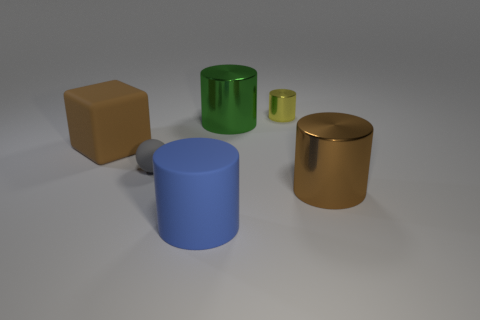Is the brown cylinder made of the same material as the small thing in front of the large brown cube?
Your answer should be very brief. No. There is a yellow cylinder that is to the right of the small object that is left of the green cylinder; how big is it?
Keep it short and to the point. Small. Are there any other things of the same color as the tiny cylinder?
Offer a very short reply. No. Do the big brown thing in front of the brown block and the large object that is to the left of the small gray sphere have the same material?
Offer a very short reply. No. There is a cylinder that is behind the tiny matte ball and on the left side of the tiny yellow metal cylinder; what material is it made of?
Give a very brief answer. Metal. There is a brown shiny thing; does it have the same shape as the shiny thing that is behind the big green object?
Your answer should be very brief. Yes. There is a cylinder right of the tiny object that is to the right of the big rubber thing in front of the large brown cylinder; what is it made of?
Provide a short and direct response. Metal. How many other things are there of the same size as the green cylinder?
Offer a terse response. 3. What number of tiny gray matte things are on the right side of the big metallic object to the left of the brown object that is on the right side of the big blue matte cylinder?
Ensure brevity in your answer.  0. What material is the large thing in front of the large shiny cylinder in front of the gray thing?
Offer a very short reply. Rubber. 